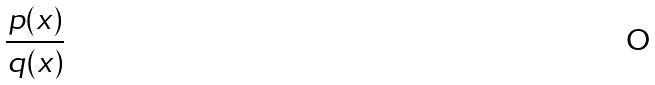<formula> <loc_0><loc_0><loc_500><loc_500>\frac { p ( x ) } { q ( x ) }</formula> 